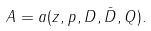Convert formula to latex. <formula><loc_0><loc_0><loc_500><loc_500>A ^ { } = a ( z ^ { } , p ^ { } , D ^ { } , \bar { D ^ { } } , Q ^ { } ) .</formula> 